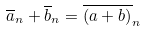Convert formula to latex. <formula><loc_0><loc_0><loc_500><loc_500>\overline { a } _ { n } + \overline { b } _ { n } = \overline { ( a + b ) } _ { n }</formula> 